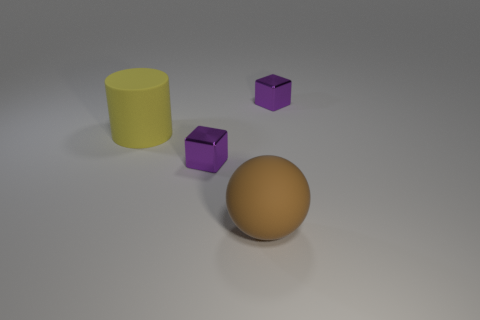Add 1 purple objects. How many objects exist? 5 Subtract all cylinders. How many objects are left? 3 Add 2 spheres. How many spheres exist? 3 Subtract 0 cyan blocks. How many objects are left? 4 Subtract all green things. Subtract all yellow rubber objects. How many objects are left? 3 Add 1 purple shiny things. How many purple shiny things are left? 3 